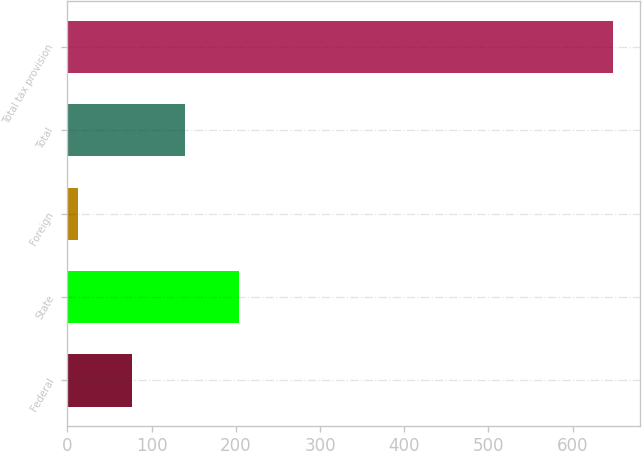Convert chart to OTSL. <chart><loc_0><loc_0><loc_500><loc_500><bar_chart><fcel>Federal<fcel>State<fcel>Foreign<fcel>Total<fcel>Total tax provision<nl><fcel>76.5<fcel>203.5<fcel>13<fcel>140<fcel>648<nl></chart> 